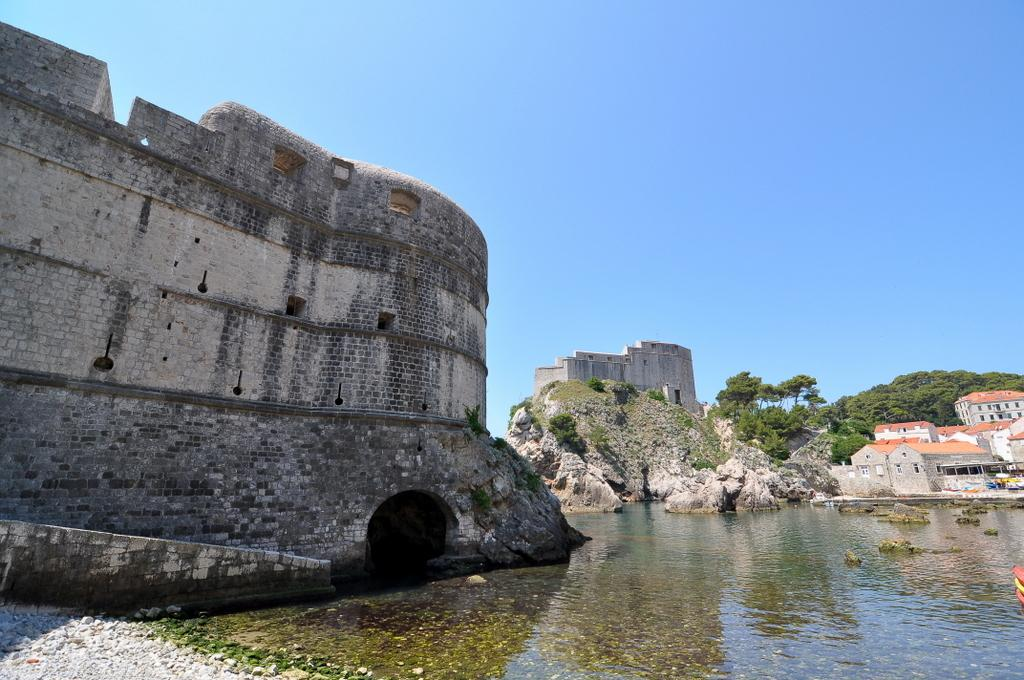What is the main structure in the center of the image? There is a fort in the center of the image. What is located in front of the fort? There is water in front of the fort. What type of natural feature can be seen on the right side of the image? There are mountains on the right side of the image. What other structures are present in the image besides the fort? There are buildings in the image. How does the fort wash its clothes in the image? The image does not show any washing of clothes, and there is no indication of a washing facility in the fort. 